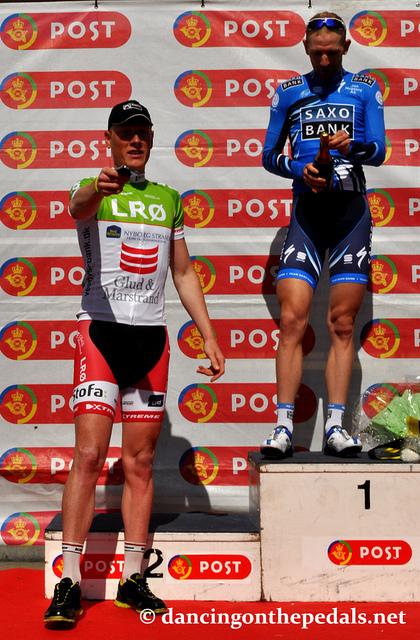Are these people fat?
Answer briefly. No. How many people are pictured in the award's ceremony?
Concise answer only. 2. What event is this?
Concise answer only. Race. What place is the man in blue?
Give a very brief answer. First. 